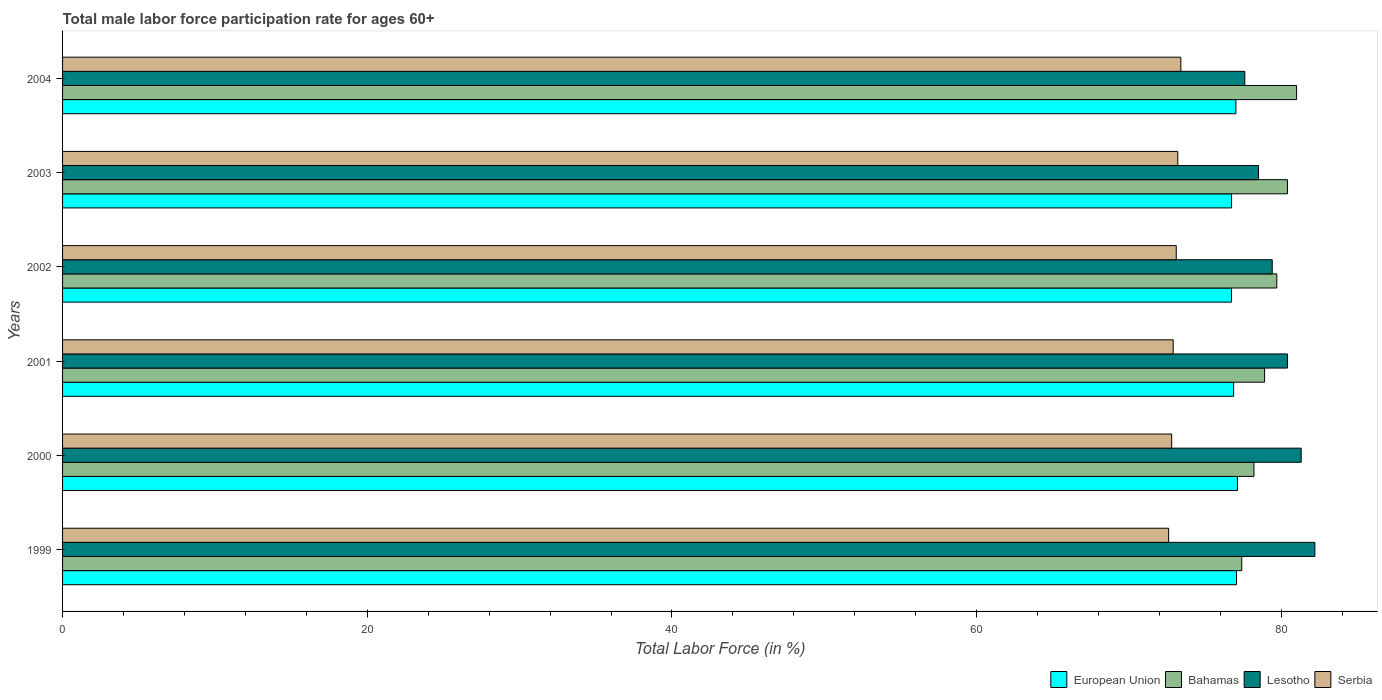How many groups of bars are there?
Offer a very short reply. 6. Are the number of bars on each tick of the Y-axis equal?
Offer a very short reply. Yes. What is the label of the 4th group of bars from the top?
Keep it short and to the point. 2001. What is the male labor force participation rate in Serbia in 2001?
Provide a succinct answer. 72.9. Across all years, what is the maximum male labor force participation rate in Lesotho?
Your answer should be compact. 82.2. Across all years, what is the minimum male labor force participation rate in Bahamas?
Provide a short and direct response. 77.4. What is the total male labor force participation rate in Lesotho in the graph?
Provide a succinct answer. 479.4. What is the difference between the male labor force participation rate in Lesotho in 2002 and that in 2003?
Provide a succinct answer. 0.9. What is the difference between the male labor force participation rate in European Union in 2004 and the male labor force participation rate in Serbia in 2002?
Keep it short and to the point. 3.92. What is the average male labor force participation rate in Serbia per year?
Keep it short and to the point. 73. In how many years, is the male labor force participation rate in Bahamas greater than 16 %?
Provide a succinct answer. 6. What is the ratio of the male labor force participation rate in European Union in 2000 to that in 2004?
Make the answer very short. 1. What is the difference between the highest and the second highest male labor force participation rate in Serbia?
Make the answer very short. 0.2. What is the difference between the highest and the lowest male labor force participation rate in European Union?
Offer a terse response. 0.39. In how many years, is the male labor force participation rate in Bahamas greater than the average male labor force participation rate in Bahamas taken over all years?
Keep it short and to the point. 3. Is it the case that in every year, the sum of the male labor force participation rate in Lesotho and male labor force participation rate in Bahamas is greater than the sum of male labor force participation rate in European Union and male labor force participation rate in Serbia?
Give a very brief answer. Yes. What does the 2nd bar from the bottom in 1999 represents?
Make the answer very short. Bahamas. Are all the bars in the graph horizontal?
Offer a very short reply. Yes. How many years are there in the graph?
Offer a very short reply. 6. What is the difference between two consecutive major ticks on the X-axis?
Your answer should be very brief. 20. Does the graph contain any zero values?
Your response must be concise. No. Does the graph contain grids?
Ensure brevity in your answer.  No. Where does the legend appear in the graph?
Provide a succinct answer. Bottom right. What is the title of the graph?
Make the answer very short. Total male labor force participation rate for ages 60+. Does "Argentina" appear as one of the legend labels in the graph?
Your answer should be very brief. No. What is the Total Labor Force (in %) in European Union in 1999?
Give a very brief answer. 77.06. What is the Total Labor Force (in %) of Bahamas in 1999?
Your answer should be very brief. 77.4. What is the Total Labor Force (in %) in Lesotho in 1999?
Ensure brevity in your answer.  82.2. What is the Total Labor Force (in %) in Serbia in 1999?
Ensure brevity in your answer.  72.6. What is the Total Labor Force (in %) of European Union in 2000?
Ensure brevity in your answer.  77.12. What is the Total Labor Force (in %) of Bahamas in 2000?
Give a very brief answer. 78.2. What is the Total Labor Force (in %) of Lesotho in 2000?
Provide a succinct answer. 81.3. What is the Total Labor Force (in %) in Serbia in 2000?
Keep it short and to the point. 72.8. What is the Total Labor Force (in %) in European Union in 2001?
Your answer should be very brief. 76.87. What is the Total Labor Force (in %) of Bahamas in 2001?
Offer a terse response. 78.9. What is the Total Labor Force (in %) of Lesotho in 2001?
Provide a short and direct response. 80.4. What is the Total Labor Force (in %) of Serbia in 2001?
Make the answer very short. 72.9. What is the Total Labor Force (in %) in European Union in 2002?
Offer a very short reply. 76.73. What is the Total Labor Force (in %) of Bahamas in 2002?
Ensure brevity in your answer.  79.7. What is the Total Labor Force (in %) of Lesotho in 2002?
Provide a succinct answer. 79.4. What is the Total Labor Force (in %) of Serbia in 2002?
Offer a very short reply. 73.1. What is the Total Labor Force (in %) of European Union in 2003?
Give a very brief answer. 76.73. What is the Total Labor Force (in %) in Bahamas in 2003?
Give a very brief answer. 80.4. What is the Total Labor Force (in %) in Lesotho in 2003?
Provide a succinct answer. 78.5. What is the Total Labor Force (in %) in Serbia in 2003?
Your response must be concise. 73.2. What is the Total Labor Force (in %) of European Union in 2004?
Offer a terse response. 77.02. What is the Total Labor Force (in %) in Lesotho in 2004?
Make the answer very short. 77.6. What is the Total Labor Force (in %) in Serbia in 2004?
Give a very brief answer. 73.4. Across all years, what is the maximum Total Labor Force (in %) of European Union?
Ensure brevity in your answer.  77.12. Across all years, what is the maximum Total Labor Force (in %) of Lesotho?
Keep it short and to the point. 82.2. Across all years, what is the maximum Total Labor Force (in %) of Serbia?
Make the answer very short. 73.4. Across all years, what is the minimum Total Labor Force (in %) in European Union?
Keep it short and to the point. 76.73. Across all years, what is the minimum Total Labor Force (in %) of Bahamas?
Provide a short and direct response. 77.4. Across all years, what is the minimum Total Labor Force (in %) in Lesotho?
Provide a succinct answer. 77.6. Across all years, what is the minimum Total Labor Force (in %) in Serbia?
Keep it short and to the point. 72.6. What is the total Total Labor Force (in %) of European Union in the graph?
Make the answer very short. 461.52. What is the total Total Labor Force (in %) in Bahamas in the graph?
Make the answer very short. 475.6. What is the total Total Labor Force (in %) in Lesotho in the graph?
Give a very brief answer. 479.4. What is the total Total Labor Force (in %) of Serbia in the graph?
Provide a succinct answer. 438. What is the difference between the Total Labor Force (in %) in European Union in 1999 and that in 2000?
Offer a terse response. -0.06. What is the difference between the Total Labor Force (in %) of Bahamas in 1999 and that in 2000?
Offer a terse response. -0.8. What is the difference between the Total Labor Force (in %) of Lesotho in 1999 and that in 2000?
Give a very brief answer. 0.9. What is the difference between the Total Labor Force (in %) of European Union in 1999 and that in 2001?
Give a very brief answer. 0.19. What is the difference between the Total Labor Force (in %) of European Union in 1999 and that in 2002?
Give a very brief answer. 0.33. What is the difference between the Total Labor Force (in %) in Serbia in 1999 and that in 2002?
Provide a succinct answer. -0.5. What is the difference between the Total Labor Force (in %) in European Union in 1999 and that in 2003?
Your response must be concise. 0.32. What is the difference between the Total Labor Force (in %) of Bahamas in 1999 and that in 2003?
Your answer should be very brief. -3. What is the difference between the Total Labor Force (in %) of Lesotho in 1999 and that in 2003?
Offer a terse response. 3.7. What is the difference between the Total Labor Force (in %) in European Union in 1999 and that in 2004?
Offer a very short reply. 0.04. What is the difference between the Total Labor Force (in %) in Lesotho in 1999 and that in 2004?
Offer a very short reply. 4.6. What is the difference between the Total Labor Force (in %) in European Union in 2000 and that in 2001?
Provide a short and direct response. 0.25. What is the difference between the Total Labor Force (in %) in Lesotho in 2000 and that in 2001?
Your response must be concise. 0.9. What is the difference between the Total Labor Force (in %) in European Union in 2000 and that in 2002?
Your answer should be very brief. 0.39. What is the difference between the Total Labor Force (in %) in Lesotho in 2000 and that in 2002?
Make the answer very short. 1.9. What is the difference between the Total Labor Force (in %) of European Union in 2000 and that in 2003?
Your response must be concise. 0.38. What is the difference between the Total Labor Force (in %) in Bahamas in 2000 and that in 2003?
Provide a short and direct response. -2.2. What is the difference between the Total Labor Force (in %) in Lesotho in 2000 and that in 2003?
Offer a terse response. 2.8. What is the difference between the Total Labor Force (in %) of European Union in 2000 and that in 2004?
Offer a very short reply. 0.1. What is the difference between the Total Labor Force (in %) of Lesotho in 2000 and that in 2004?
Provide a short and direct response. 3.7. What is the difference between the Total Labor Force (in %) of European Union in 2001 and that in 2002?
Your response must be concise. 0.14. What is the difference between the Total Labor Force (in %) in Bahamas in 2001 and that in 2002?
Your answer should be compact. -0.8. What is the difference between the Total Labor Force (in %) in Serbia in 2001 and that in 2002?
Make the answer very short. -0.2. What is the difference between the Total Labor Force (in %) in European Union in 2001 and that in 2003?
Make the answer very short. 0.13. What is the difference between the Total Labor Force (in %) in Bahamas in 2001 and that in 2003?
Keep it short and to the point. -1.5. What is the difference between the Total Labor Force (in %) in Lesotho in 2001 and that in 2003?
Offer a terse response. 1.9. What is the difference between the Total Labor Force (in %) in European Union in 2001 and that in 2004?
Make the answer very short. -0.15. What is the difference between the Total Labor Force (in %) in European Union in 2002 and that in 2003?
Provide a succinct answer. -0. What is the difference between the Total Labor Force (in %) of Bahamas in 2002 and that in 2003?
Your response must be concise. -0.7. What is the difference between the Total Labor Force (in %) of Lesotho in 2002 and that in 2003?
Make the answer very short. 0.9. What is the difference between the Total Labor Force (in %) of European Union in 2002 and that in 2004?
Offer a terse response. -0.29. What is the difference between the Total Labor Force (in %) in Lesotho in 2002 and that in 2004?
Ensure brevity in your answer.  1.8. What is the difference between the Total Labor Force (in %) in Serbia in 2002 and that in 2004?
Your answer should be very brief. -0.3. What is the difference between the Total Labor Force (in %) in European Union in 2003 and that in 2004?
Provide a succinct answer. -0.28. What is the difference between the Total Labor Force (in %) in Bahamas in 2003 and that in 2004?
Ensure brevity in your answer.  -0.6. What is the difference between the Total Labor Force (in %) in Serbia in 2003 and that in 2004?
Offer a very short reply. -0.2. What is the difference between the Total Labor Force (in %) in European Union in 1999 and the Total Labor Force (in %) in Bahamas in 2000?
Ensure brevity in your answer.  -1.14. What is the difference between the Total Labor Force (in %) of European Union in 1999 and the Total Labor Force (in %) of Lesotho in 2000?
Offer a terse response. -4.24. What is the difference between the Total Labor Force (in %) in European Union in 1999 and the Total Labor Force (in %) in Serbia in 2000?
Your answer should be compact. 4.26. What is the difference between the Total Labor Force (in %) in European Union in 1999 and the Total Labor Force (in %) in Bahamas in 2001?
Provide a short and direct response. -1.84. What is the difference between the Total Labor Force (in %) of European Union in 1999 and the Total Labor Force (in %) of Lesotho in 2001?
Your answer should be very brief. -3.34. What is the difference between the Total Labor Force (in %) of European Union in 1999 and the Total Labor Force (in %) of Serbia in 2001?
Offer a very short reply. 4.16. What is the difference between the Total Labor Force (in %) of Bahamas in 1999 and the Total Labor Force (in %) of Lesotho in 2001?
Offer a terse response. -3. What is the difference between the Total Labor Force (in %) in European Union in 1999 and the Total Labor Force (in %) in Bahamas in 2002?
Offer a terse response. -2.64. What is the difference between the Total Labor Force (in %) of European Union in 1999 and the Total Labor Force (in %) of Lesotho in 2002?
Offer a terse response. -2.34. What is the difference between the Total Labor Force (in %) of European Union in 1999 and the Total Labor Force (in %) of Serbia in 2002?
Make the answer very short. 3.96. What is the difference between the Total Labor Force (in %) in Bahamas in 1999 and the Total Labor Force (in %) in Lesotho in 2002?
Your answer should be compact. -2. What is the difference between the Total Labor Force (in %) in Bahamas in 1999 and the Total Labor Force (in %) in Serbia in 2002?
Ensure brevity in your answer.  4.3. What is the difference between the Total Labor Force (in %) of Lesotho in 1999 and the Total Labor Force (in %) of Serbia in 2002?
Provide a succinct answer. 9.1. What is the difference between the Total Labor Force (in %) of European Union in 1999 and the Total Labor Force (in %) of Bahamas in 2003?
Your answer should be very brief. -3.34. What is the difference between the Total Labor Force (in %) in European Union in 1999 and the Total Labor Force (in %) in Lesotho in 2003?
Make the answer very short. -1.44. What is the difference between the Total Labor Force (in %) of European Union in 1999 and the Total Labor Force (in %) of Serbia in 2003?
Make the answer very short. 3.86. What is the difference between the Total Labor Force (in %) in European Union in 1999 and the Total Labor Force (in %) in Bahamas in 2004?
Offer a very short reply. -3.94. What is the difference between the Total Labor Force (in %) in European Union in 1999 and the Total Labor Force (in %) in Lesotho in 2004?
Give a very brief answer. -0.54. What is the difference between the Total Labor Force (in %) in European Union in 1999 and the Total Labor Force (in %) in Serbia in 2004?
Make the answer very short. 3.66. What is the difference between the Total Labor Force (in %) of Bahamas in 1999 and the Total Labor Force (in %) of Serbia in 2004?
Offer a very short reply. 4. What is the difference between the Total Labor Force (in %) in European Union in 2000 and the Total Labor Force (in %) in Bahamas in 2001?
Offer a very short reply. -1.78. What is the difference between the Total Labor Force (in %) of European Union in 2000 and the Total Labor Force (in %) of Lesotho in 2001?
Offer a terse response. -3.28. What is the difference between the Total Labor Force (in %) in European Union in 2000 and the Total Labor Force (in %) in Serbia in 2001?
Make the answer very short. 4.22. What is the difference between the Total Labor Force (in %) in Bahamas in 2000 and the Total Labor Force (in %) in Lesotho in 2001?
Your response must be concise. -2.2. What is the difference between the Total Labor Force (in %) of Bahamas in 2000 and the Total Labor Force (in %) of Serbia in 2001?
Provide a short and direct response. 5.3. What is the difference between the Total Labor Force (in %) in European Union in 2000 and the Total Labor Force (in %) in Bahamas in 2002?
Provide a short and direct response. -2.58. What is the difference between the Total Labor Force (in %) of European Union in 2000 and the Total Labor Force (in %) of Lesotho in 2002?
Give a very brief answer. -2.28. What is the difference between the Total Labor Force (in %) in European Union in 2000 and the Total Labor Force (in %) in Serbia in 2002?
Offer a terse response. 4.02. What is the difference between the Total Labor Force (in %) in European Union in 2000 and the Total Labor Force (in %) in Bahamas in 2003?
Offer a very short reply. -3.28. What is the difference between the Total Labor Force (in %) in European Union in 2000 and the Total Labor Force (in %) in Lesotho in 2003?
Your answer should be very brief. -1.38. What is the difference between the Total Labor Force (in %) in European Union in 2000 and the Total Labor Force (in %) in Serbia in 2003?
Keep it short and to the point. 3.92. What is the difference between the Total Labor Force (in %) of Bahamas in 2000 and the Total Labor Force (in %) of Lesotho in 2003?
Your answer should be very brief. -0.3. What is the difference between the Total Labor Force (in %) in European Union in 2000 and the Total Labor Force (in %) in Bahamas in 2004?
Offer a very short reply. -3.88. What is the difference between the Total Labor Force (in %) of European Union in 2000 and the Total Labor Force (in %) of Lesotho in 2004?
Provide a short and direct response. -0.48. What is the difference between the Total Labor Force (in %) in European Union in 2000 and the Total Labor Force (in %) in Serbia in 2004?
Offer a very short reply. 3.72. What is the difference between the Total Labor Force (in %) in Bahamas in 2000 and the Total Labor Force (in %) in Lesotho in 2004?
Provide a succinct answer. 0.6. What is the difference between the Total Labor Force (in %) in Bahamas in 2000 and the Total Labor Force (in %) in Serbia in 2004?
Give a very brief answer. 4.8. What is the difference between the Total Labor Force (in %) in Lesotho in 2000 and the Total Labor Force (in %) in Serbia in 2004?
Your answer should be very brief. 7.9. What is the difference between the Total Labor Force (in %) of European Union in 2001 and the Total Labor Force (in %) of Bahamas in 2002?
Ensure brevity in your answer.  -2.83. What is the difference between the Total Labor Force (in %) of European Union in 2001 and the Total Labor Force (in %) of Lesotho in 2002?
Your answer should be very brief. -2.53. What is the difference between the Total Labor Force (in %) of European Union in 2001 and the Total Labor Force (in %) of Serbia in 2002?
Offer a very short reply. 3.77. What is the difference between the Total Labor Force (in %) in European Union in 2001 and the Total Labor Force (in %) in Bahamas in 2003?
Your answer should be very brief. -3.53. What is the difference between the Total Labor Force (in %) of European Union in 2001 and the Total Labor Force (in %) of Lesotho in 2003?
Your answer should be compact. -1.63. What is the difference between the Total Labor Force (in %) in European Union in 2001 and the Total Labor Force (in %) in Serbia in 2003?
Make the answer very short. 3.67. What is the difference between the Total Labor Force (in %) of Bahamas in 2001 and the Total Labor Force (in %) of Serbia in 2003?
Provide a short and direct response. 5.7. What is the difference between the Total Labor Force (in %) of European Union in 2001 and the Total Labor Force (in %) of Bahamas in 2004?
Your response must be concise. -4.13. What is the difference between the Total Labor Force (in %) of European Union in 2001 and the Total Labor Force (in %) of Lesotho in 2004?
Make the answer very short. -0.73. What is the difference between the Total Labor Force (in %) in European Union in 2001 and the Total Labor Force (in %) in Serbia in 2004?
Offer a terse response. 3.47. What is the difference between the Total Labor Force (in %) of Bahamas in 2001 and the Total Labor Force (in %) of Serbia in 2004?
Your answer should be very brief. 5.5. What is the difference between the Total Labor Force (in %) in European Union in 2002 and the Total Labor Force (in %) in Bahamas in 2003?
Provide a succinct answer. -3.67. What is the difference between the Total Labor Force (in %) in European Union in 2002 and the Total Labor Force (in %) in Lesotho in 2003?
Your answer should be compact. -1.77. What is the difference between the Total Labor Force (in %) in European Union in 2002 and the Total Labor Force (in %) in Serbia in 2003?
Offer a very short reply. 3.53. What is the difference between the Total Labor Force (in %) of Bahamas in 2002 and the Total Labor Force (in %) of Serbia in 2003?
Provide a succinct answer. 6.5. What is the difference between the Total Labor Force (in %) of Lesotho in 2002 and the Total Labor Force (in %) of Serbia in 2003?
Your response must be concise. 6.2. What is the difference between the Total Labor Force (in %) in European Union in 2002 and the Total Labor Force (in %) in Bahamas in 2004?
Give a very brief answer. -4.27. What is the difference between the Total Labor Force (in %) of European Union in 2002 and the Total Labor Force (in %) of Lesotho in 2004?
Provide a short and direct response. -0.87. What is the difference between the Total Labor Force (in %) in European Union in 2002 and the Total Labor Force (in %) in Serbia in 2004?
Offer a terse response. 3.33. What is the difference between the Total Labor Force (in %) in Lesotho in 2002 and the Total Labor Force (in %) in Serbia in 2004?
Make the answer very short. 6. What is the difference between the Total Labor Force (in %) of European Union in 2003 and the Total Labor Force (in %) of Bahamas in 2004?
Give a very brief answer. -4.27. What is the difference between the Total Labor Force (in %) in European Union in 2003 and the Total Labor Force (in %) in Lesotho in 2004?
Your answer should be compact. -0.87. What is the difference between the Total Labor Force (in %) in European Union in 2003 and the Total Labor Force (in %) in Serbia in 2004?
Ensure brevity in your answer.  3.33. What is the average Total Labor Force (in %) in European Union per year?
Offer a terse response. 76.92. What is the average Total Labor Force (in %) in Bahamas per year?
Provide a short and direct response. 79.27. What is the average Total Labor Force (in %) in Lesotho per year?
Your answer should be compact. 79.9. What is the average Total Labor Force (in %) of Serbia per year?
Provide a short and direct response. 73. In the year 1999, what is the difference between the Total Labor Force (in %) of European Union and Total Labor Force (in %) of Bahamas?
Provide a succinct answer. -0.34. In the year 1999, what is the difference between the Total Labor Force (in %) of European Union and Total Labor Force (in %) of Lesotho?
Your response must be concise. -5.14. In the year 1999, what is the difference between the Total Labor Force (in %) of European Union and Total Labor Force (in %) of Serbia?
Provide a short and direct response. 4.46. In the year 1999, what is the difference between the Total Labor Force (in %) in Bahamas and Total Labor Force (in %) in Lesotho?
Ensure brevity in your answer.  -4.8. In the year 2000, what is the difference between the Total Labor Force (in %) in European Union and Total Labor Force (in %) in Bahamas?
Keep it short and to the point. -1.08. In the year 2000, what is the difference between the Total Labor Force (in %) in European Union and Total Labor Force (in %) in Lesotho?
Provide a succinct answer. -4.18. In the year 2000, what is the difference between the Total Labor Force (in %) of European Union and Total Labor Force (in %) of Serbia?
Give a very brief answer. 4.32. In the year 2000, what is the difference between the Total Labor Force (in %) of Bahamas and Total Labor Force (in %) of Serbia?
Give a very brief answer. 5.4. In the year 2000, what is the difference between the Total Labor Force (in %) of Lesotho and Total Labor Force (in %) of Serbia?
Keep it short and to the point. 8.5. In the year 2001, what is the difference between the Total Labor Force (in %) of European Union and Total Labor Force (in %) of Bahamas?
Ensure brevity in your answer.  -2.03. In the year 2001, what is the difference between the Total Labor Force (in %) in European Union and Total Labor Force (in %) in Lesotho?
Keep it short and to the point. -3.53. In the year 2001, what is the difference between the Total Labor Force (in %) of European Union and Total Labor Force (in %) of Serbia?
Your answer should be compact. 3.97. In the year 2001, what is the difference between the Total Labor Force (in %) in Bahamas and Total Labor Force (in %) in Serbia?
Your answer should be compact. 6. In the year 2002, what is the difference between the Total Labor Force (in %) of European Union and Total Labor Force (in %) of Bahamas?
Offer a very short reply. -2.97. In the year 2002, what is the difference between the Total Labor Force (in %) in European Union and Total Labor Force (in %) in Lesotho?
Keep it short and to the point. -2.67. In the year 2002, what is the difference between the Total Labor Force (in %) in European Union and Total Labor Force (in %) in Serbia?
Ensure brevity in your answer.  3.63. In the year 2002, what is the difference between the Total Labor Force (in %) of Bahamas and Total Labor Force (in %) of Lesotho?
Your answer should be compact. 0.3. In the year 2002, what is the difference between the Total Labor Force (in %) of Lesotho and Total Labor Force (in %) of Serbia?
Ensure brevity in your answer.  6.3. In the year 2003, what is the difference between the Total Labor Force (in %) in European Union and Total Labor Force (in %) in Bahamas?
Keep it short and to the point. -3.67. In the year 2003, what is the difference between the Total Labor Force (in %) in European Union and Total Labor Force (in %) in Lesotho?
Your answer should be compact. -1.77. In the year 2003, what is the difference between the Total Labor Force (in %) in European Union and Total Labor Force (in %) in Serbia?
Offer a very short reply. 3.53. In the year 2003, what is the difference between the Total Labor Force (in %) in Bahamas and Total Labor Force (in %) in Lesotho?
Make the answer very short. 1.9. In the year 2003, what is the difference between the Total Labor Force (in %) of Bahamas and Total Labor Force (in %) of Serbia?
Make the answer very short. 7.2. In the year 2003, what is the difference between the Total Labor Force (in %) in Lesotho and Total Labor Force (in %) in Serbia?
Provide a short and direct response. 5.3. In the year 2004, what is the difference between the Total Labor Force (in %) in European Union and Total Labor Force (in %) in Bahamas?
Your response must be concise. -3.98. In the year 2004, what is the difference between the Total Labor Force (in %) of European Union and Total Labor Force (in %) of Lesotho?
Provide a short and direct response. -0.58. In the year 2004, what is the difference between the Total Labor Force (in %) of European Union and Total Labor Force (in %) of Serbia?
Offer a very short reply. 3.62. In the year 2004, what is the difference between the Total Labor Force (in %) in Bahamas and Total Labor Force (in %) in Lesotho?
Keep it short and to the point. 3.4. In the year 2004, what is the difference between the Total Labor Force (in %) in Bahamas and Total Labor Force (in %) in Serbia?
Ensure brevity in your answer.  7.6. What is the ratio of the Total Labor Force (in %) in Bahamas in 1999 to that in 2000?
Your answer should be very brief. 0.99. What is the ratio of the Total Labor Force (in %) of Lesotho in 1999 to that in 2000?
Ensure brevity in your answer.  1.01. What is the ratio of the Total Labor Force (in %) in Serbia in 1999 to that in 2000?
Offer a terse response. 1. What is the ratio of the Total Labor Force (in %) in Lesotho in 1999 to that in 2001?
Keep it short and to the point. 1.02. What is the ratio of the Total Labor Force (in %) of European Union in 1999 to that in 2002?
Make the answer very short. 1. What is the ratio of the Total Labor Force (in %) of Bahamas in 1999 to that in 2002?
Give a very brief answer. 0.97. What is the ratio of the Total Labor Force (in %) in Lesotho in 1999 to that in 2002?
Offer a very short reply. 1.04. What is the ratio of the Total Labor Force (in %) of Bahamas in 1999 to that in 2003?
Provide a short and direct response. 0.96. What is the ratio of the Total Labor Force (in %) in Lesotho in 1999 to that in 2003?
Ensure brevity in your answer.  1.05. What is the ratio of the Total Labor Force (in %) in Bahamas in 1999 to that in 2004?
Provide a succinct answer. 0.96. What is the ratio of the Total Labor Force (in %) of Lesotho in 1999 to that in 2004?
Provide a short and direct response. 1.06. What is the ratio of the Total Labor Force (in %) of Serbia in 1999 to that in 2004?
Your response must be concise. 0.99. What is the ratio of the Total Labor Force (in %) in Lesotho in 2000 to that in 2001?
Give a very brief answer. 1.01. What is the ratio of the Total Labor Force (in %) in Serbia in 2000 to that in 2001?
Your answer should be compact. 1. What is the ratio of the Total Labor Force (in %) in Bahamas in 2000 to that in 2002?
Provide a short and direct response. 0.98. What is the ratio of the Total Labor Force (in %) of Lesotho in 2000 to that in 2002?
Your response must be concise. 1.02. What is the ratio of the Total Labor Force (in %) of European Union in 2000 to that in 2003?
Your answer should be very brief. 1. What is the ratio of the Total Labor Force (in %) of Bahamas in 2000 to that in 2003?
Your answer should be very brief. 0.97. What is the ratio of the Total Labor Force (in %) in Lesotho in 2000 to that in 2003?
Your answer should be very brief. 1.04. What is the ratio of the Total Labor Force (in %) in Bahamas in 2000 to that in 2004?
Ensure brevity in your answer.  0.97. What is the ratio of the Total Labor Force (in %) in Lesotho in 2000 to that in 2004?
Offer a very short reply. 1.05. What is the ratio of the Total Labor Force (in %) in Serbia in 2000 to that in 2004?
Offer a very short reply. 0.99. What is the ratio of the Total Labor Force (in %) of European Union in 2001 to that in 2002?
Make the answer very short. 1. What is the ratio of the Total Labor Force (in %) in Lesotho in 2001 to that in 2002?
Make the answer very short. 1.01. What is the ratio of the Total Labor Force (in %) of Serbia in 2001 to that in 2002?
Ensure brevity in your answer.  1. What is the ratio of the Total Labor Force (in %) of Bahamas in 2001 to that in 2003?
Keep it short and to the point. 0.98. What is the ratio of the Total Labor Force (in %) of Lesotho in 2001 to that in 2003?
Ensure brevity in your answer.  1.02. What is the ratio of the Total Labor Force (in %) of European Union in 2001 to that in 2004?
Provide a succinct answer. 1. What is the ratio of the Total Labor Force (in %) of Bahamas in 2001 to that in 2004?
Offer a very short reply. 0.97. What is the ratio of the Total Labor Force (in %) in Lesotho in 2001 to that in 2004?
Your answer should be very brief. 1.04. What is the ratio of the Total Labor Force (in %) in Serbia in 2001 to that in 2004?
Provide a short and direct response. 0.99. What is the ratio of the Total Labor Force (in %) in European Union in 2002 to that in 2003?
Your response must be concise. 1. What is the ratio of the Total Labor Force (in %) in Bahamas in 2002 to that in 2003?
Provide a succinct answer. 0.99. What is the ratio of the Total Labor Force (in %) in Lesotho in 2002 to that in 2003?
Your answer should be very brief. 1.01. What is the ratio of the Total Labor Force (in %) of European Union in 2002 to that in 2004?
Offer a very short reply. 1. What is the ratio of the Total Labor Force (in %) of Lesotho in 2002 to that in 2004?
Your answer should be very brief. 1.02. What is the ratio of the Total Labor Force (in %) of Serbia in 2002 to that in 2004?
Provide a short and direct response. 1. What is the ratio of the Total Labor Force (in %) in European Union in 2003 to that in 2004?
Your answer should be very brief. 1. What is the ratio of the Total Labor Force (in %) of Bahamas in 2003 to that in 2004?
Your answer should be compact. 0.99. What is the ratio of the Total Labor Force (in %) of Lesotho in 2003 to that in 2004?
Provide a short and direct response. 1.01. What is the difference between the highest and the second highest Total Labor Force (in %) in European Union?
Provide a short and direct response. 0.06. What is the difference between the highest and the second highest Total Labor Force (in %) of Lesotho?
Provide a short and direct response. 0.9. What is the difference between the highest and the lowest Total Labor Force (in %) of European Union?
Offer a very short reply. 0.39. What is the difference between the highest and the lowest Total Labor Force (in %) of Bahamas?
Your answer should be very brief. 3.6. 